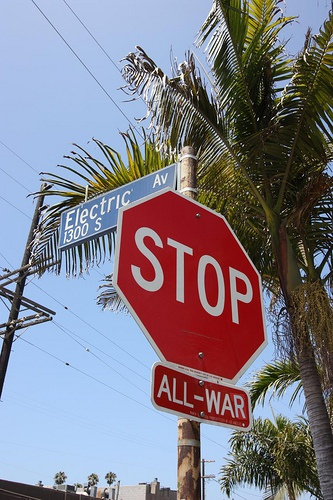Describe the objects in this image and their specific colors. I can see a stop sign in lavender, maroon, darkgray, and brown tones in this image. 